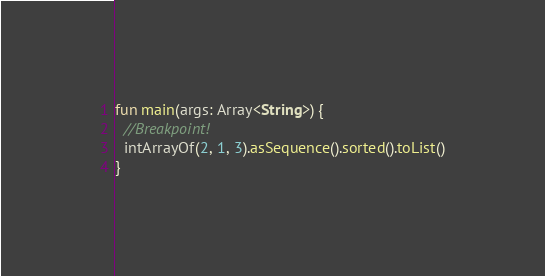<code> <loc_0><loc_0><loc_500><loc_500><_Kotlin_>fun main(args: Array<String>) {
  //Breakpoint!
  intArrayOf(2, 1, 3).asSequence().sorted().toList()
}</code> 